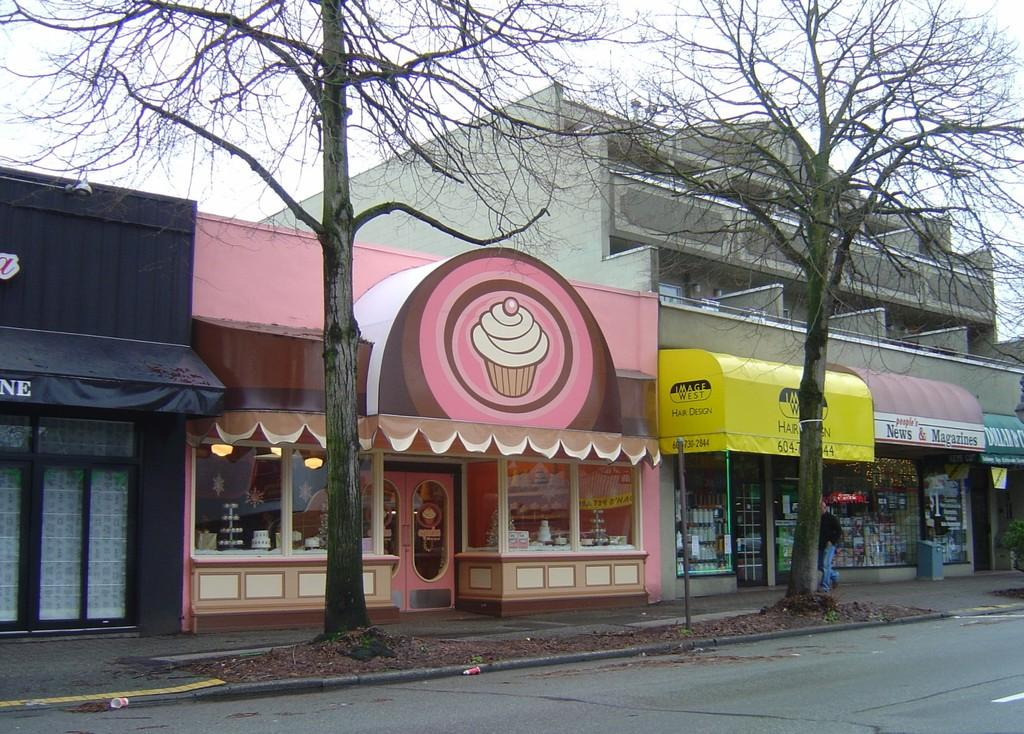What type of structure is present in the image? There is a building in the image. What can be found inside the building? There are stores in the building. What natural elements can be seen in the image? Trees are visible in the image. How can the stores be identified in the image? There are name boards in the image. What is the weather like in the image? The sky is cloudy in the image. How many pigs are supporting the building in the image? There are no pigs present in the image, and they are not supporting the building. What type of stamp can be seen on the name boards in the image? There is no stamp visible on the name boards in the image. 